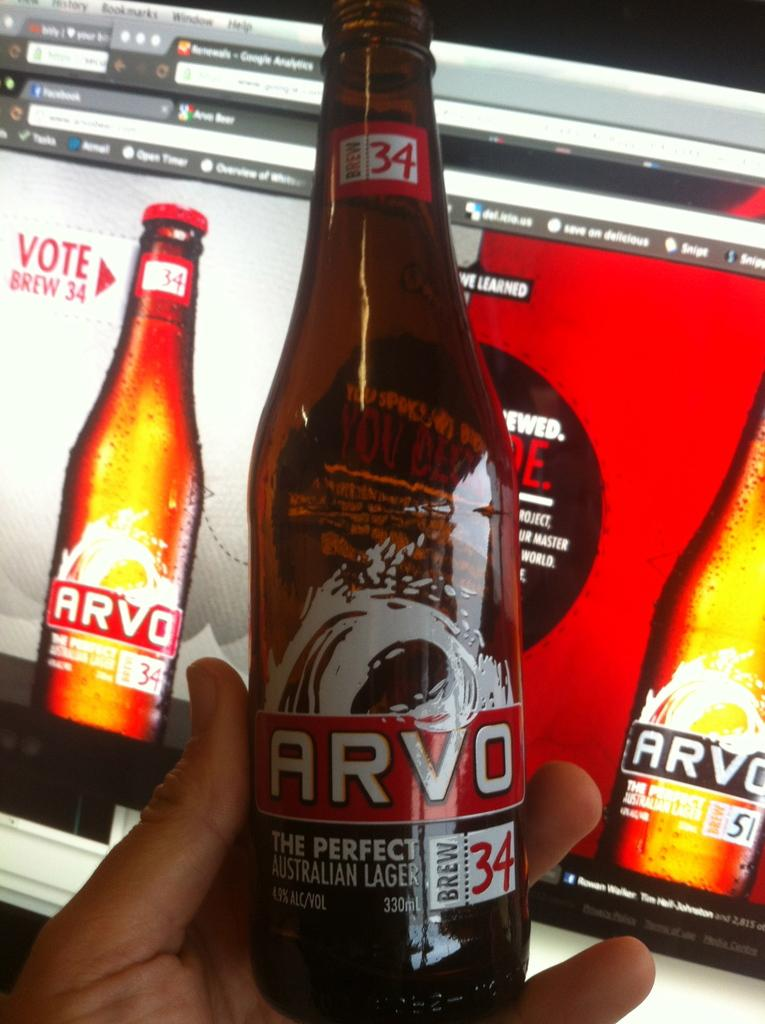What is the main subject of the image? The main subject of the image is a human hand. What is the hand holding in the image? The hand is holding a bottle in the image. What can be seen behind the bottle? A: There is a screen visible behind the bottle in the image. What type of secretary is sitting next to the hand in the image? There is no secretary present in the image; it only features a human hand holding a bottle with a screen visible behind it. 